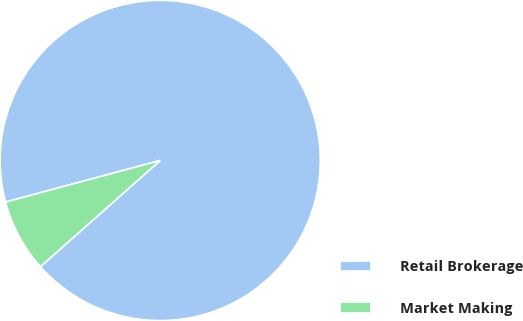Convert chart to OTSL. <chart><loc_0><loc_0><loc_500><loc_500><pie_chart><fcel>Retail Brokerage<fcel>Market Making<nl><fcel>92.64%<fcel>7.36%<nl></chart> 